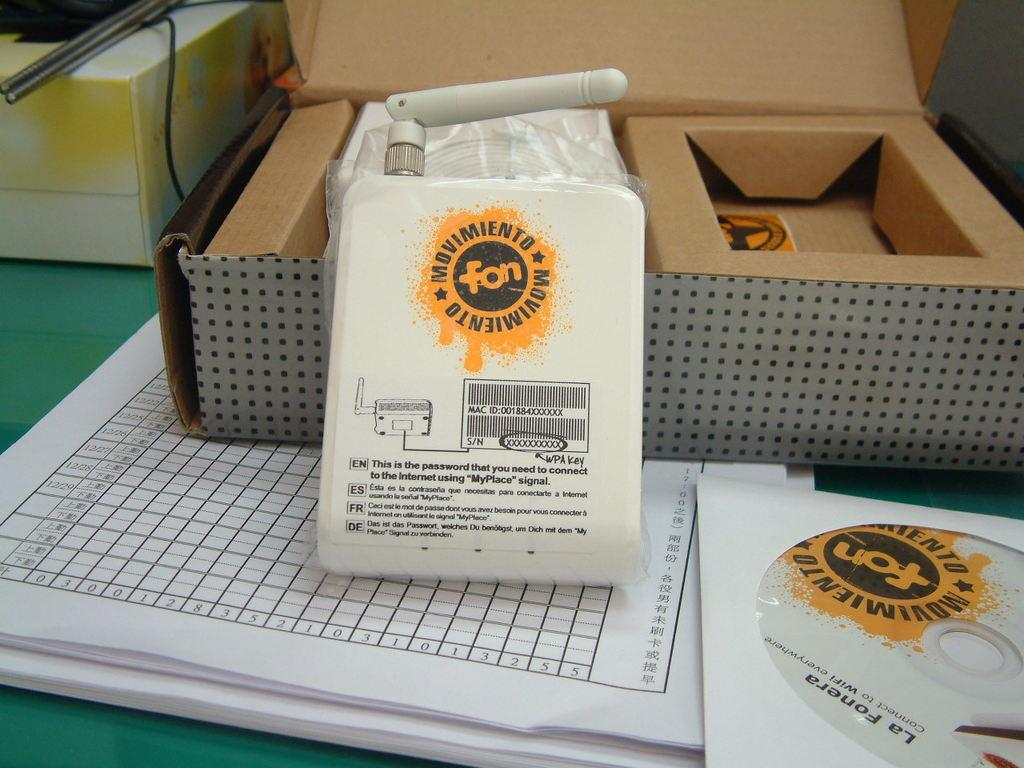<image>
Summarize the visual content of the image. White bag which says "Movimiento" in a yellow circle. 